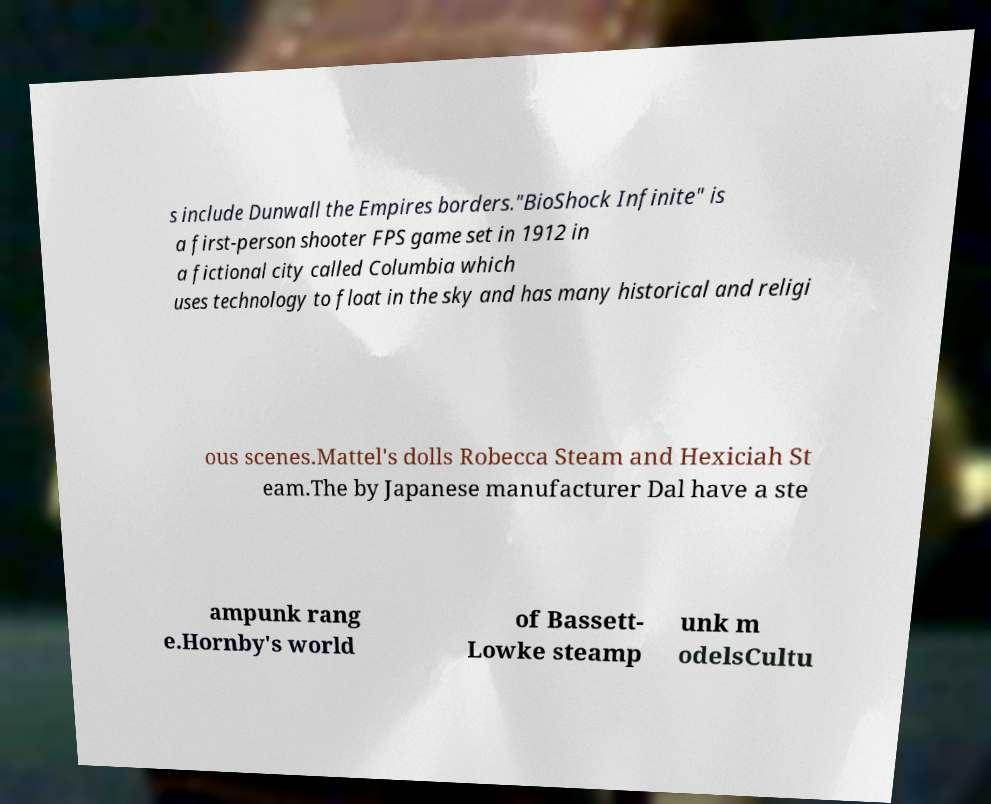I need the written content from this picture converted into text. Can you do that? s include Dunwall the Empires borders."BioShock Infinite" is a first-person shooter FPS game set in 1912 in a fictional city called Columbia which uses technology to float in the sky and has many historical and religi ous scenes.Mattel's dolls Robecca Steam and Hexiciah St eam.The by Japanese manufacturer Dal have a ste ampunk rang e.Hornby's world of Bassett- Lowke steamp unk m odelsCultu 